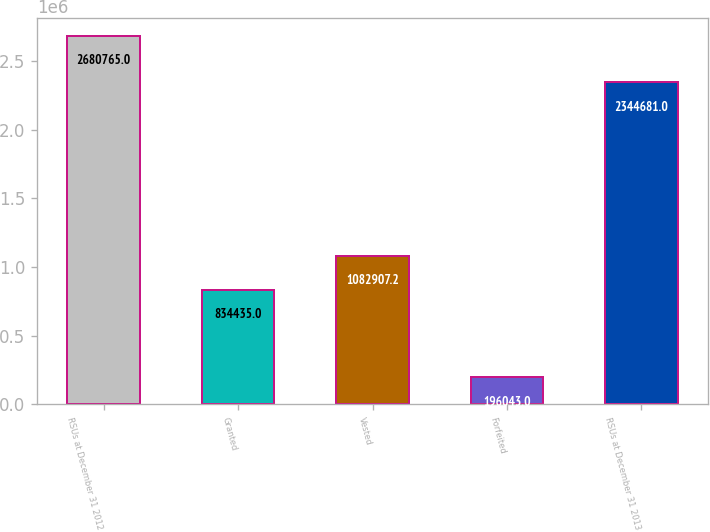Convert chart. <chart><loc_0><loc_0><loc_500><loc_500><bar_chart><fcel>RSUs at December 31 2012<fcel>Granted<fcel>Vested<fcel>Forfeited<fcel>RSUs at December 31 2013<nl><fcel>2.68076e+06<fcel>834435<fcel>1.08291e+06<fcel>196043<fcel>2.34468e+06<nl></chart> 